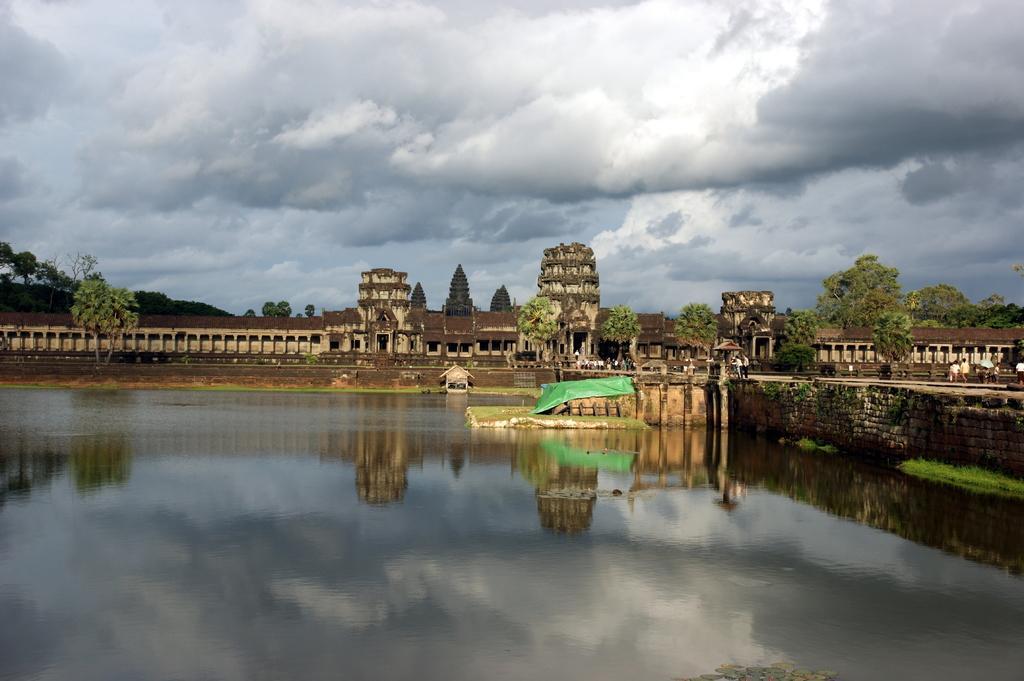Can you describe this image briefly? In this picture I can see water, there are group of people, there are buildings, there are trees, and in the background there is the sky. 